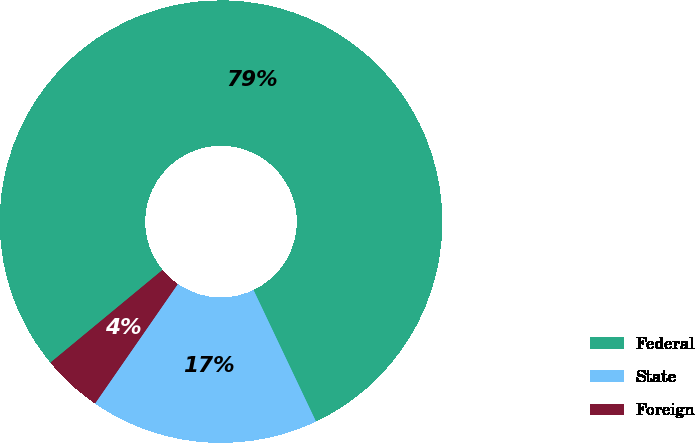Convert chart to OTSL. <chart><loc_0><loc_0><loc_500><loc_500><pie_chart><fcel>Federal<fcel>State<fcel>Foreign<nl><fcel>78.93%<fcel>16.7%<fcel>4.36%<nl></chart> 